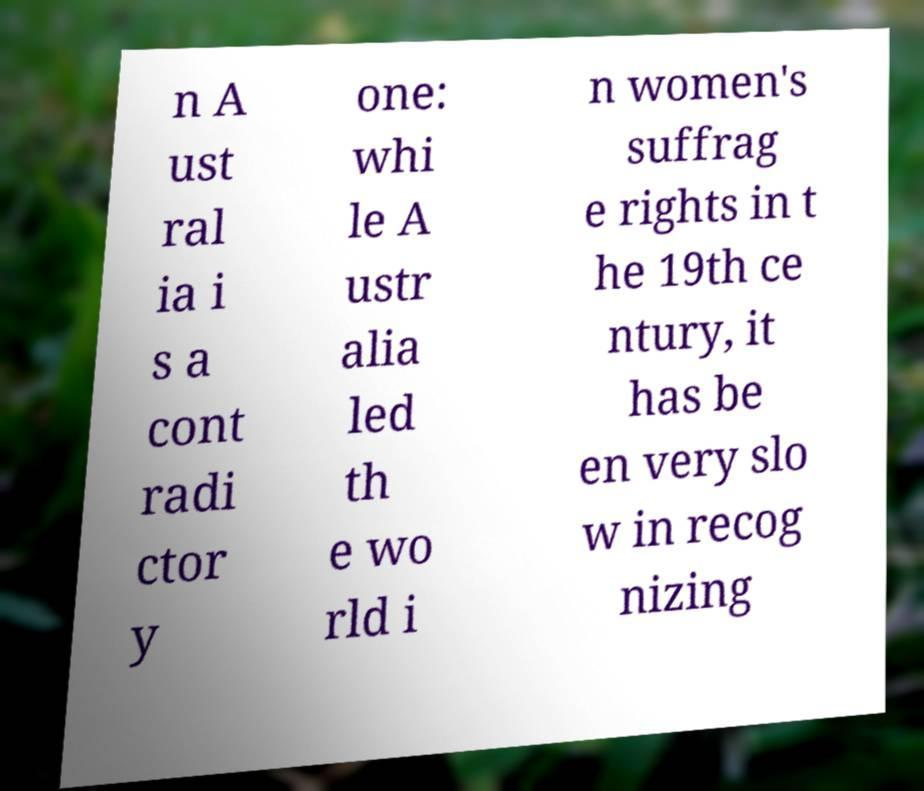Please read and relay the text visible in this image. What does it say? n A ust ral ia i s a cont radi ctor y one: whi le A ustr alia led th e wo rld i n women's suffrag e rights in t he 19th ce ntury, it has be en very slo w in recog nizing 